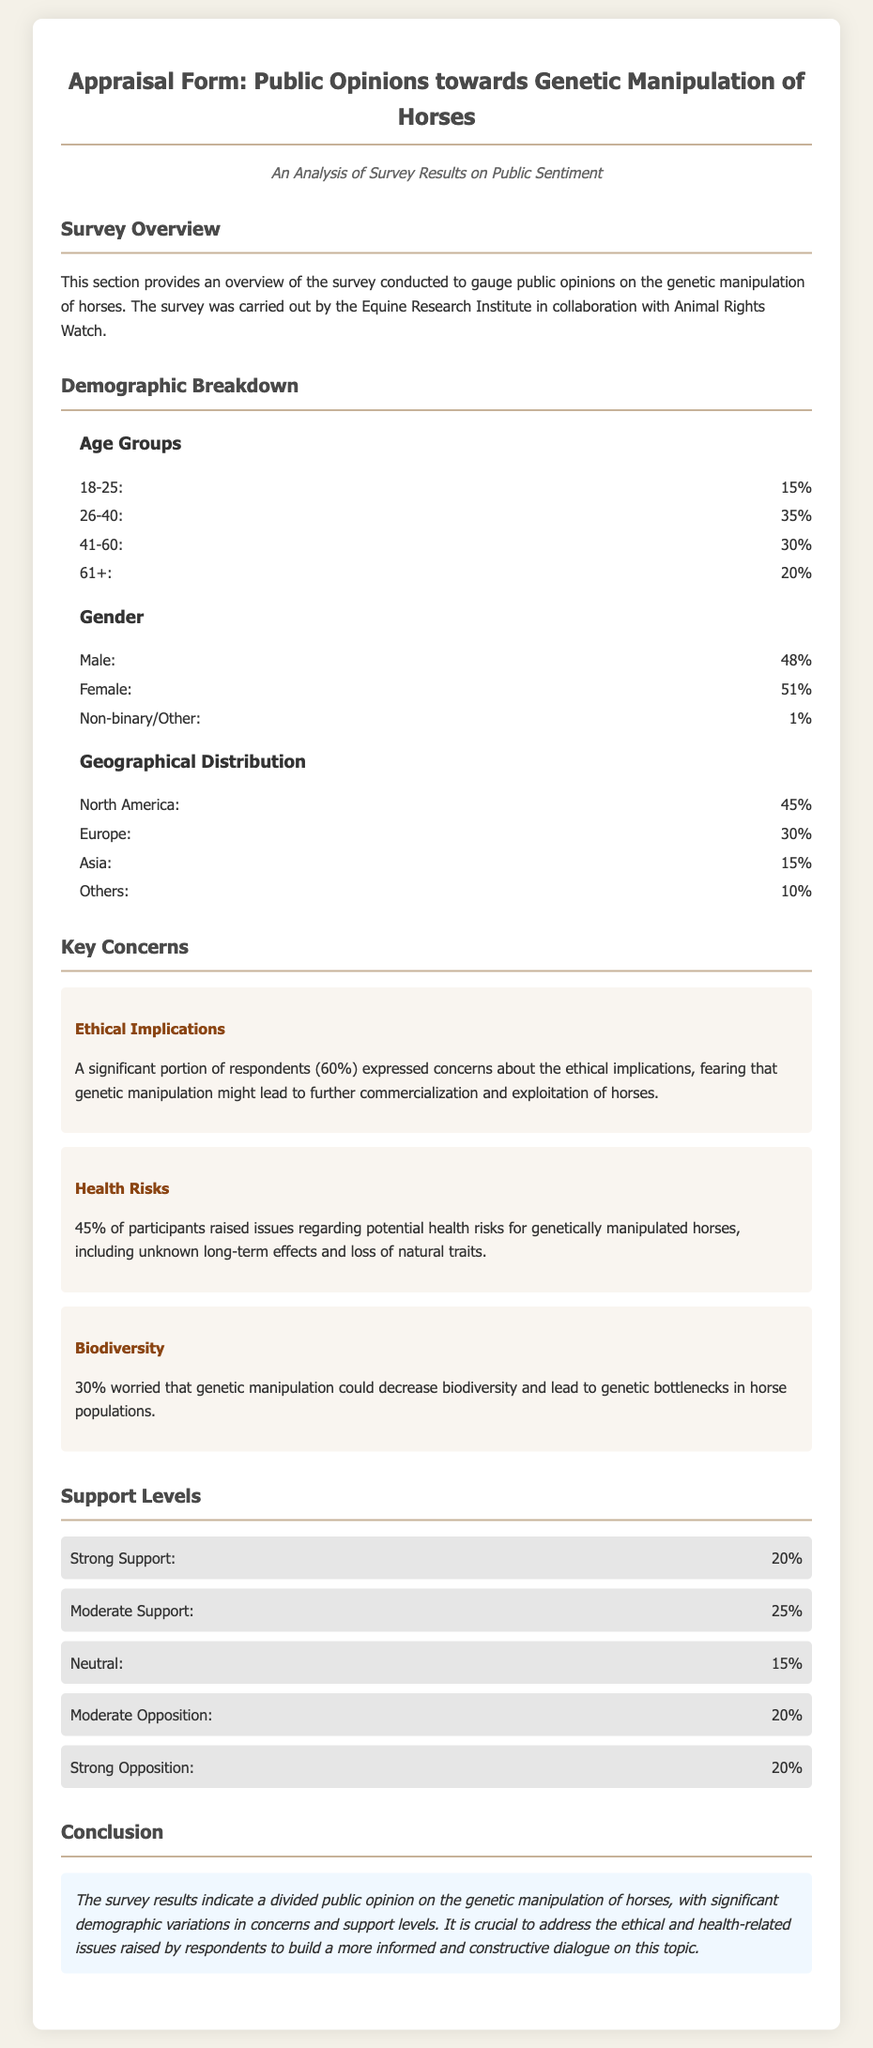What percentage of respondents are in the age group 41-60? The document states that 30% of respondents fall in the age group of 41-60.
Answer: 30% What is the largest demographic group by gender? According to the document, 51% of respondents identified as Female, making it the largest demographic group.
Answer: Female What percentage expressed concerns about ethical implications? The document indicates that 60% of respondents expressed concerns regarding the ethical implications of genetic manipulation.
Answer: 60% What is the combined percentage of respondents that support genetic manipulation (strong and moderate support)? The document lists 20% for strong support and 25% for moderate support, totaling 45%.
Answer: 45% What percentage of respondents are located in North America? The survey results show that 45% of respondents are from North America.
Answer: 45% What concern was raised by 30% of the participants? The document states that 30% of participants worried about potential decreases in biodiversity.
Answer: Biodiversity What total percentage represents moderate to strong opposition to genetic manipulation? The document shows that both moderate and strong opposition each account for 20%, totaling 40%.
Answer: 40% What is the title of the document? The document is titled "Appraisal Form: Public Opinions towards Genetic Manipulation of Horses."
Answer: Appraisal Form: Public Opinions towards Genetic Manipulation of Horses How many respondents are non-binary or identify as other? The document states that 1% of respondents fall under the non-binary or other category.
Answer: 1% 